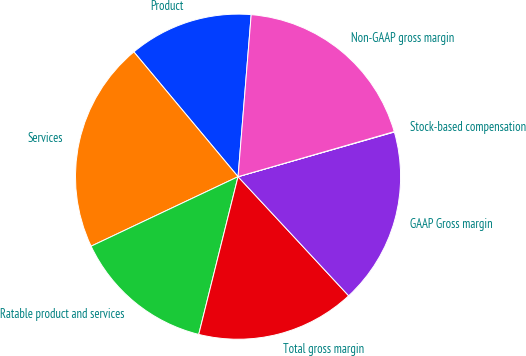Convert chart. <chart><loc_0><loc_0><loc_500><loc_500><pie_chart><fcel>Product<fcel>Services<fcel>Ratable product and services<fcel>Total gross margin<fcel>GAAP Gross margin<fcel>Stock-based compensation<fcel>Non-GAAP gross margin<nl><fcel>12.36%<fcel>20.96%<fcel>14.08%<fcel>15.8%<fcel>17.52%<fcel>0.04%<fcel>19.24%<nl></chart> 